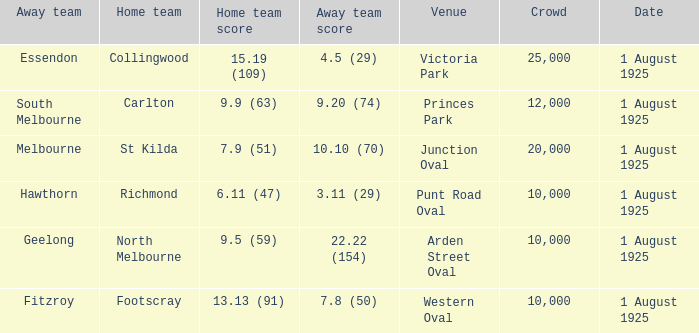Which match where Hawthorn was the away team had the largest crowd? 10000.0. 